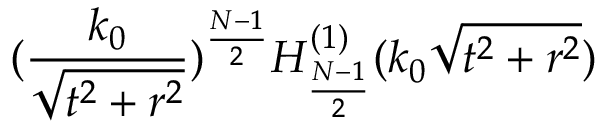<formula> <loc_0><loc_0><loc_500><loc_500>( \frac { k _ { 0 } } { \sqrt { t ^ { 2 } + r ^ { 2 } } } ) ^ { \frac { N - 1 } { 2 } } H _ { \frac { N - 1 } { 2 } } ^ { ( 1 ) } ( k _ { 0 } \sqrt { t ^ { 2 } + r ^ { 2 } } )</formula> 